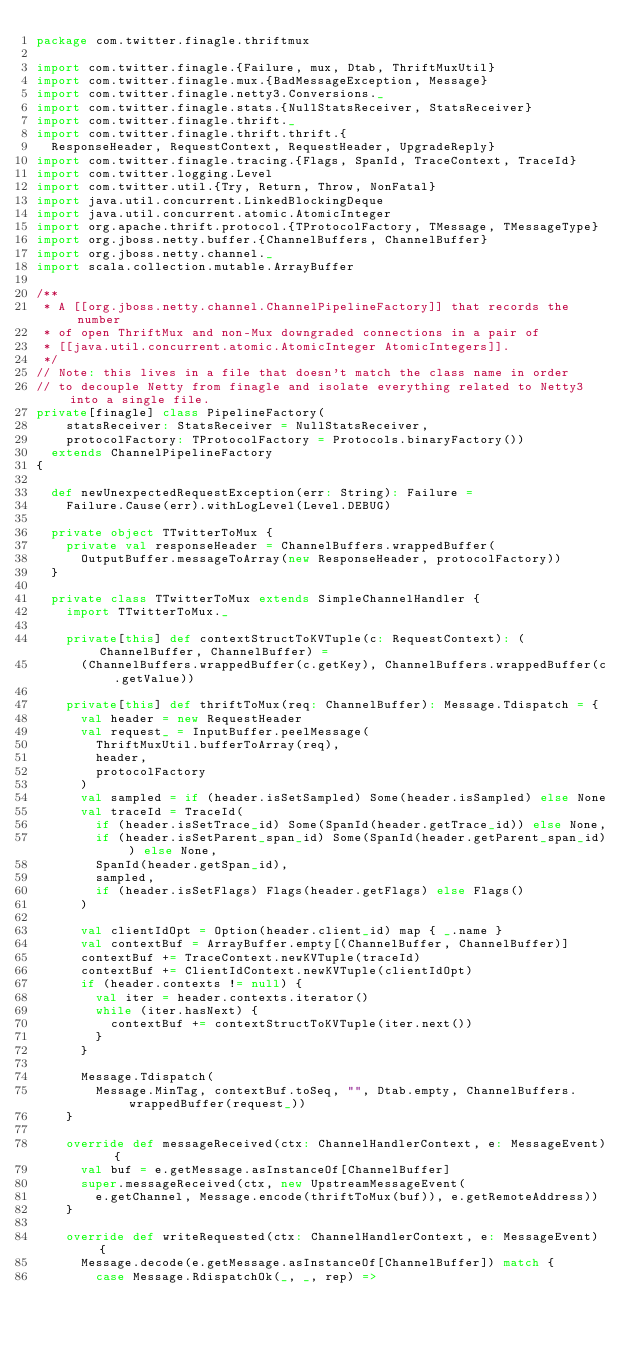Convert code to text. <code><loc_0><loc_0><loc_500><loc_500><_Scala_>package com.twitter.finagle.thriftmux

import com.twitter.finagle.{Failure, mux, Dtab, ThriftMuxUtil}
import com.twitter.finagle.mux.{BadMessageException, Message}
import com.twitter.finagle.netty3.Conversions._
import com.twitter.finagle.stats.{NullStatsReceiver, StatsReceiver}
import com.twitter.finagle.thrift._
import com.twitter.finagle.thrift.thrift.{
  ResponseHeader, RequestContext, RequestHeader, UpgradeReply}
import com.twitter.finagle.tracing.{Flags, SpanId, TraceContext, TraceId}
import com.twitter.logging.Level
import com.twitter.util.{Try, Return, Throw, NonFatal}
import java.util.concurrent.LinkedBlockingDeque
import java.util.concurrent.atomic.AtomicInteger
import org.apache.thrift.protocol.{TProtocolFactory, TMessage, TMessageType}
import org.jboss.netty.buffer.{ChannelBuffers, ChannelBuffer}
import org.jboss.netty.channel._
import scala.collection.mutable.ArrayBuffer

/**
 * A [[org.jboss.netty.channel.ChannelPipelineFactory]] that records the number
 * of open ThriftMux and non-Mux downgraded connections in a pair of
 * [[java.util.concurrent.atomic.AtomicInteger AtomicIntegers]].
 */
// Note: this lives in a file that doesn't match the class name in order
// to decouple Netty from finagle and isolate everything related to Netty3 into a single file.
private[finagle] class PipelineFactory(
    statsReceiver: StatsReceiver = NullStatsReceiver,
    protocolFactory: TProtocolFactory = Protocols.binaryFactory())
  extends ChannelPipelineFactory
{

  def newUnexpectedRequestException(err: String): Failure =
    Failure.Cause(err).withLogLevel(Level.DEBUG)

  private object TTwitterToMux {
    private val responseHeader = ChannelBuffers.wrappedBuffer(
      OutputBuffer.messageToArray(new ResponseHeader, protocolFactory))
  }

  private class TTwitterToMux extends SimpleChannelHandler {
    import TTwitterToMux._

    private[this] def contextStructToKVTuple(c: RequestContext): (ChannelBuffer, ChannelBuffer) =
      (ChannelBuffers.wrappedBuffer(c.getKey), ChannelBuffers.wrappedBuffer(c.getValue))

    private[this] def thriftToMux(req: ChannelBuffer): Message.Tdispatch = {
      val header = new RequestHeader
      val request_ = InputBuffer.peelMessage(
        ThriftMuxUtil.bufferToArray(req),
        header,
        protocolFactory
      )
      val sampled = if (header.isSetSampled) Some(header.isSampled) else None
      val traceId = TraceId(
        if (header.isSetTrace_id) Some(SpanId(header.getTrace_id)) else None,
        if (header.isSetParent_span_id) Some(SpanId(header.getParent_span_id)) else None,
        SpanId(header.getSpan_id),
        sampled,
        if (header.isSetFlags) Flags(header.getFlags) else Flags()
      )

      val clientIdOpt = Option(header.client_id) map { _.name }
      val contextBuf = ArrayBuffer.empty[(ChannelBuffer, ChannelBuffer)]
      contextBuf += TraceContext.newKVTuple(traceId)
      contextBuf += ClientIdContext.newKVTuple(clientIdOpt)
      if (header.contexts != null) {
        val iter = header.contexts.iterator()
        while (iter.hasNext) {
          contextBuf += contextStructToKVTuple(iter.next())
        }
      }

      Message.Tdispatch(
        Message.MinTag, contextBuf.toSeq, "", Dtab.empty, ChannelBuffers.wrappedBuffer(request_))
    }

    override def messageReceived(ctx: ChannelHandlerContext, e: MessageEvent)  {
      val buf = e.getMessage.asInstanceOf[ChannelBuffer]
      super.messageReceived(ctx, new UpstreamMessageEvent(
        e.getChannel, Message.encode(thriftToMux(buf)), e.getRemoteAddress))
    }

    override def writeRequested(ctx: ChannelHandlerContext, e: MessageEvent) {
      Message.decode(e.getMessage.asInstanceOf[ChannelBuffer]) match {
        case Message.RdispatchOk(_, _, rep) =></code> 